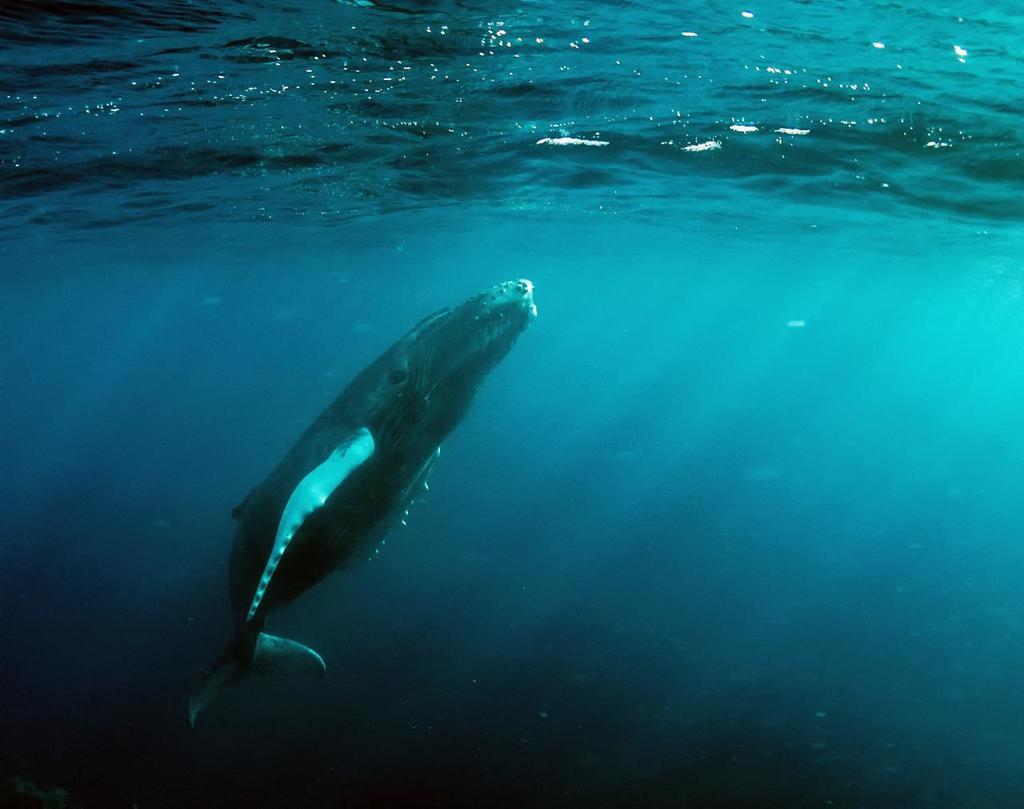What type of animal can be seen in the image? There is an aquatic animal in the image. Where is the aquatic animal located? The aquatic animal is in the water. What type of alley can be seen in the image? There is no alley present in the image; it features an aquatic animal in the water. 